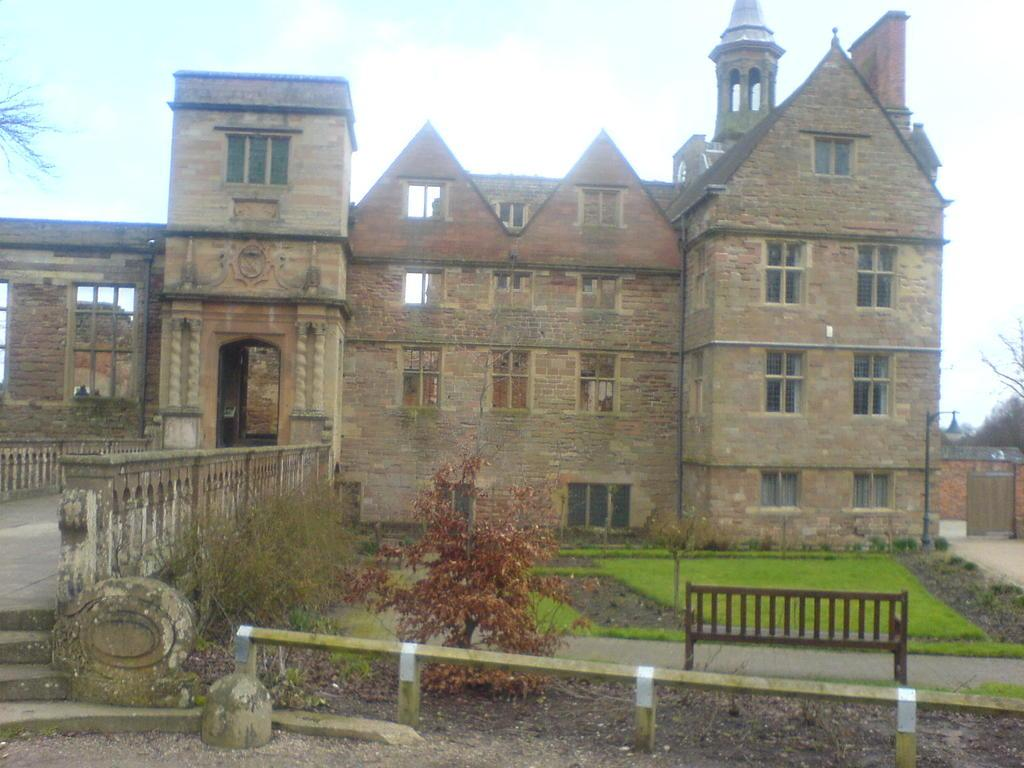What can be seen at the front of the image? There are railings, plants, grass, a bench, and a light pole in the front of the image. What type of objects are present in the front of the image? There are objects such as railings, plants, and a bench in the front of the image. What is visible in the background of the image? There is a building, trees, and sky visible in the background of the image. What type of objects can be seen in the background of the image? There are objects such as a building and trees in the background of the image. Can you tell me how many leaves are on the eggnog in the image? There is no eggnog present in the image, and therefore no leaves can be found on it. How does the bench help the plants in the image? The bench does not actively help the plants in the image; it is simply a separate object located nearby. 